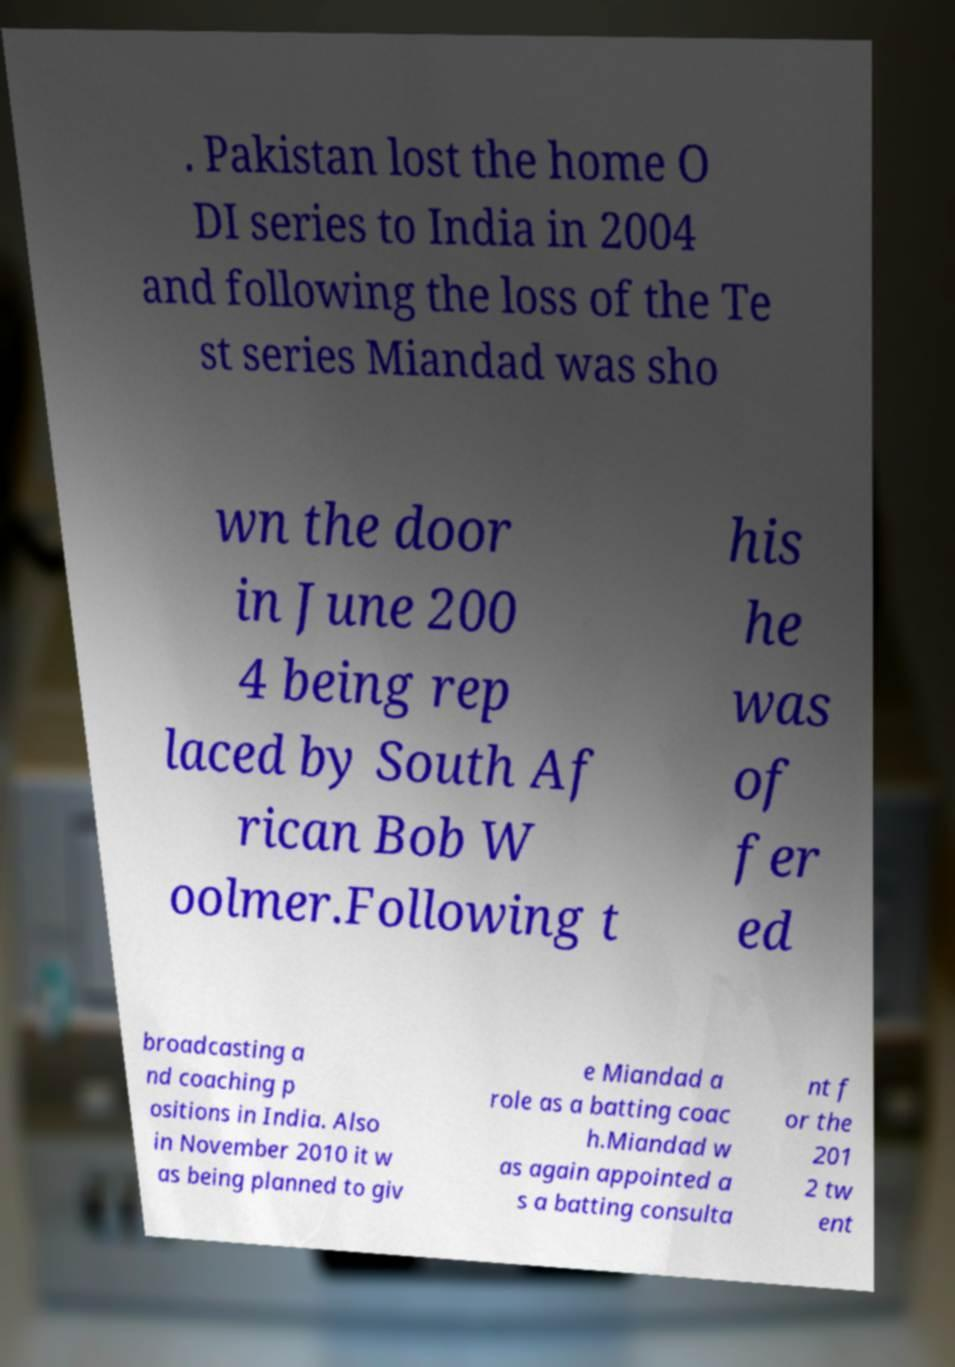For documentation purposes, I need the text within this image transcribed. Could you provide that? . Pakistan lost the home O DI series to India in 2004 and following the loss of the Te st series Miandad was sho wn the door in June 200 4 being rep laced by South Af rican Bob W oolmer.Following t his he was of fer ed broadcasting a nd coaching p ositions in India. Also in November 2010 it w as being planned to giv e Miandad a role as a batting coac h.Miandad w as again appointed a s a batting consulta nt f or the 201 2 tw ent 